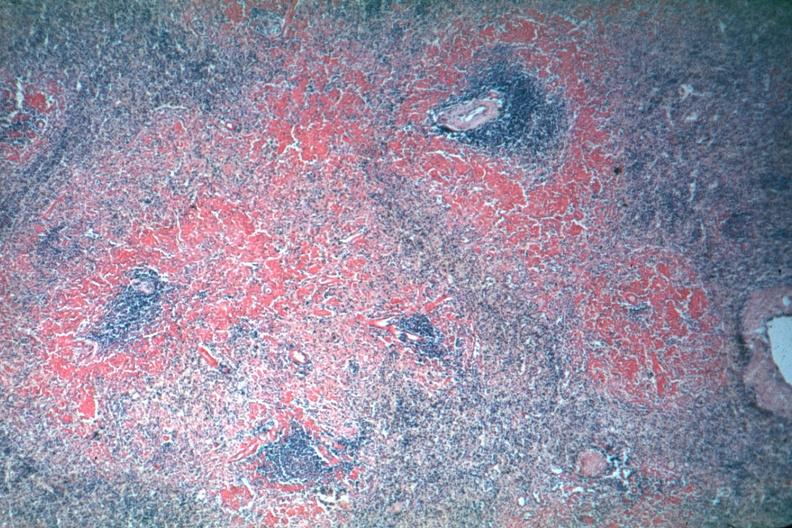s hematologic present?
Answer the question using a single word or phrase. Yes 